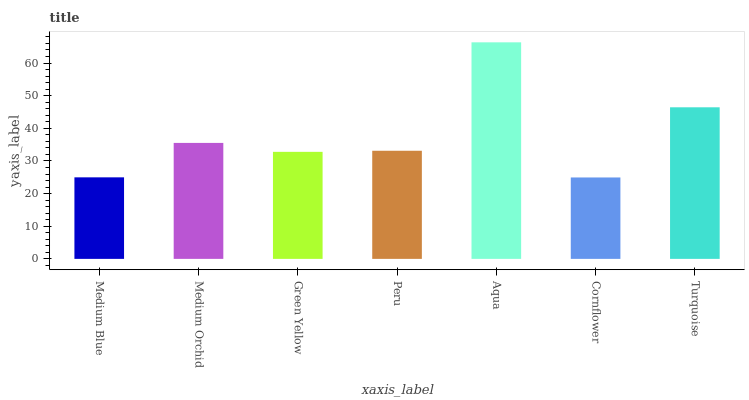Is Cornflower the minimum?
Answer yes or no. Yes. Is Aqua the maximum?
Answer yes or no. Yes. Is Medium Orchid the minimum?
Answer yes or no. No. Is Medium Orchid the maximum?
Answer yes or no. No. Is Medium Orchid greater than Medium Blue?
Answer yes or no. Yes. Is Medium Blue less than Medium Orchid?
Answer yes or no. Yes. Is Medium Blue greater than Medium Orchid?
Answer yes or no. No. Is Medium Orchid less than Medium Blue?
Answer yes or no. No. Is Peru the high median?
Answer yes or no. Yes. Is Peru the low median?
Answer yes or no. Yes. Is Aqua the high median?
Answer yes or no. No. Is Cornflower the low median?
Answer yes or no. No. 